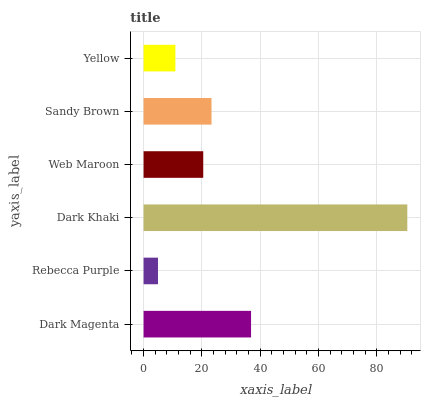Is Rebecca Purple the minimum?
Answer yes or no. Yes. Is Dark Khaki the maximum?
Answer yes or no. Yes. Is Dark Khaki the minimum?
Answer yes or no. No. Is Rebecca Purple the maximum?
Answer yes or no. No. Is Dark Khaki greater than Rebecca Purple?
Answer yes or no. Yes. Is Rebecca Purple less than Dark Khaki?
Answer yes or no. Yes. Is Rebecca Purple greater than Dark Khaki?
Answer yes or no. No. Is Dark Khaki less than Rebecca Purple?
Answer yes or no. No. Is Sandy Brown the high median?
Answer yes or no. Yes. Is Web Maroon the low median?
Answer yes or no. Yes. Is Web Maroon the high median?
Answer yes or no. No. Is Dark Khaki the low median?
Answer yes or no. No. 